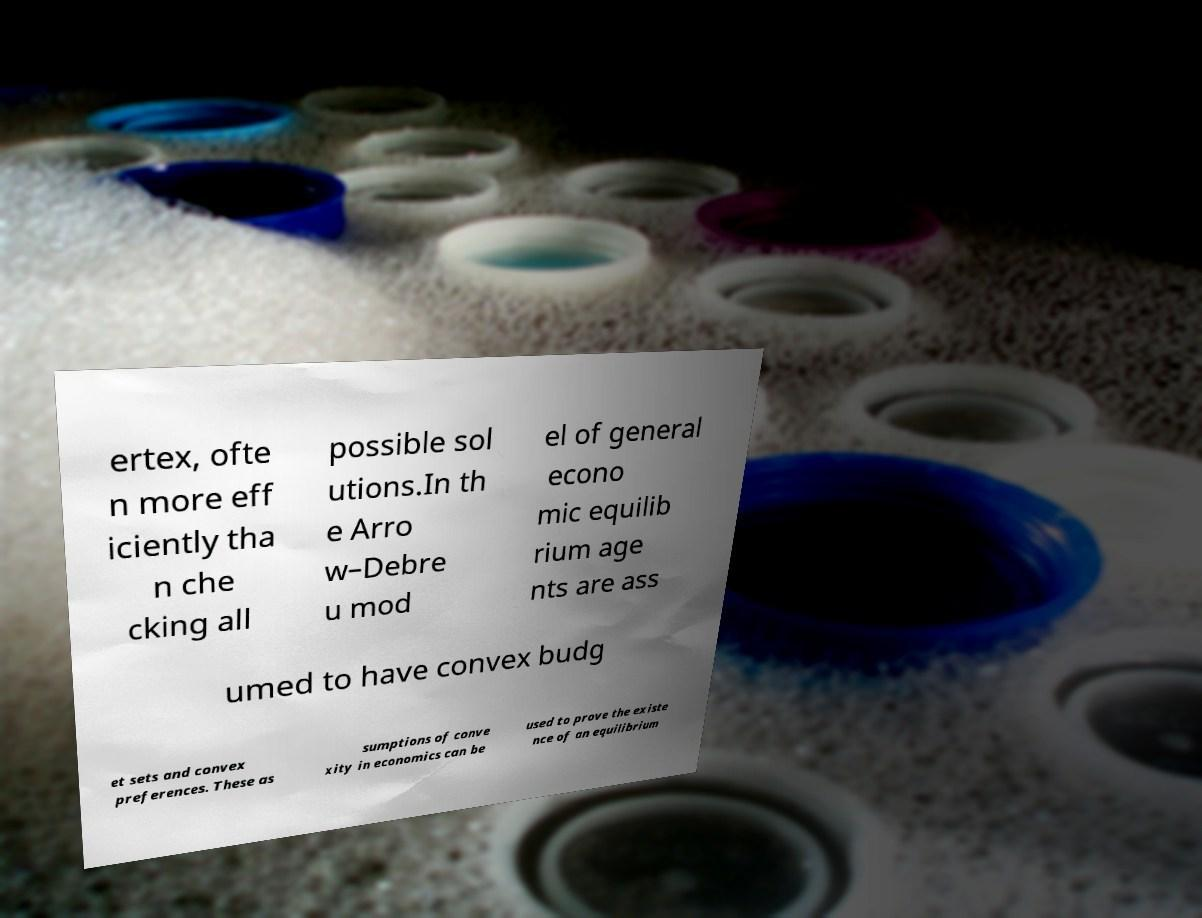Please identify and transcribe the text found in this image. ertex, ofte n more eff iciently tha n che cking all possible sol utions.In th e Arro w–Debre u mod el of general econo mic equilib rium age nts are ass umed to have convex budg et sets and convex preferences. These as sumptions of conve xity in economics can be used to prove the existe nce of an equilibrium 